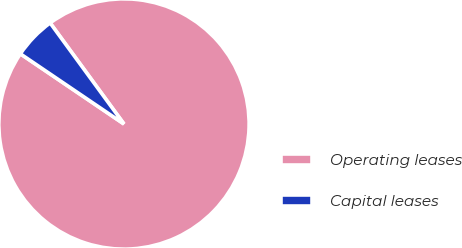<chart> <loc_0><loc_0><loc_500><loc_500><pie_chart><fcel>Operating leases<fcel>Capital leases<nl><fcel>94.52%<fcel>5.48%<nl></chart> 